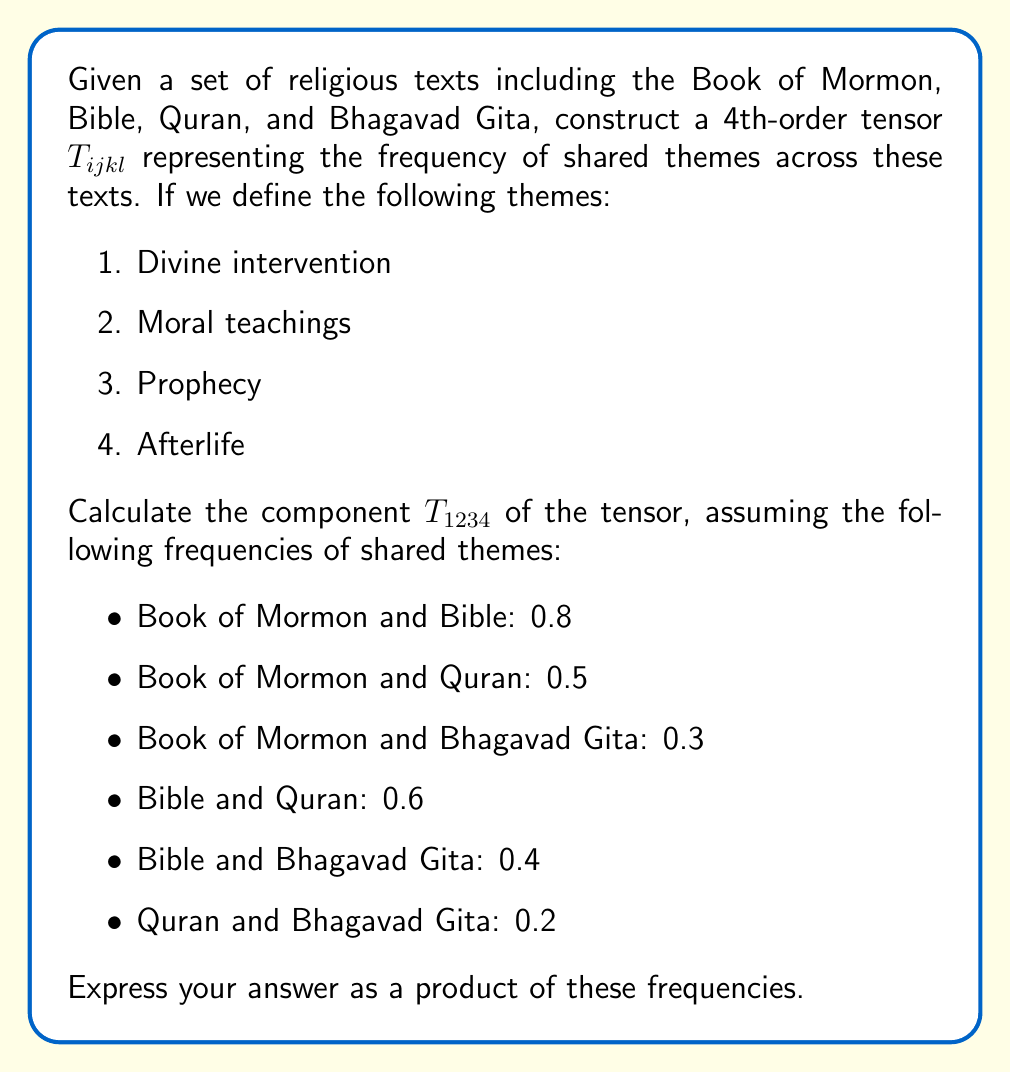Could you help me with this problem? To solve this problem, we need to follow these steps:

1) First, let's understand what the indices of the tensor $T_{ijkl}$ represent:
   - $i$: Book of Mormon
   - $j$: Bible
   - $k$: Quran
   - $l$: Bhagavad Gita

2) The component $T_{1234}$ represents the frequency of the first theme (Divine intervention) being shared across all four texts simultaneously.

3) To calculate this, we need to multiply the frequencies of shared themes between each pair of texts:

   $$T_{1234} = f_{12} \cdot f_{13} \cdot f_{14} \cdot f_{23} \cdot f_{24} \cdot f_{34}$$

   Where $f_{ij}$ represents the frequency of shared themes between text $i$ and text $j$.

4) Now, let's substitute the given frequencies:

   $$T_{1234} = 0.8 \cdot 0.5 \cdot 0.3 \cdot 0.6 \cdot 0.4 \cdot 0.2$$

5) Multiplying these values:

   $$T_{1234} = 0.00576$$

This result represents the likelihood of the theme "Divine intervention" being shared across all four religious texts simultaneously, based on the given pairwise frequencies.
Answer: $T_{1234} = 0.00576$ 